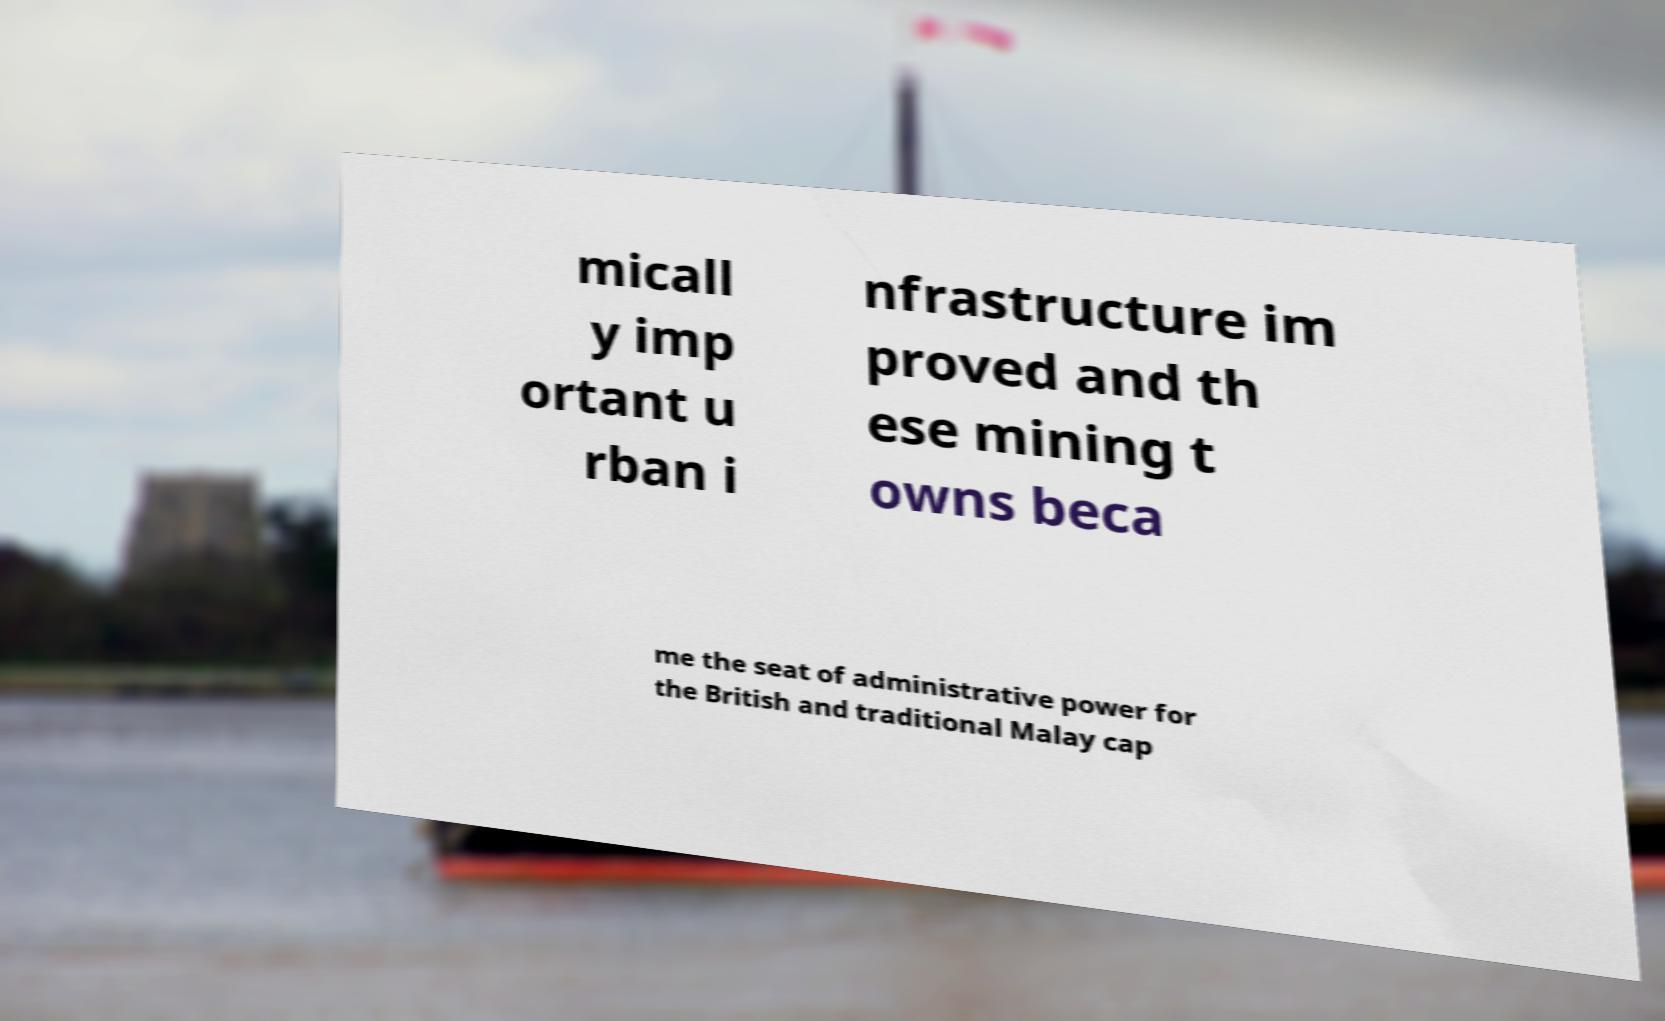What messages or text are displayed in this image? I need them in a readable, typed format. micall y imp ortant u rban i nfrastructure im proved and th ese mining t owns beca me the seat of administrative power for the British and traditional Malay cap 